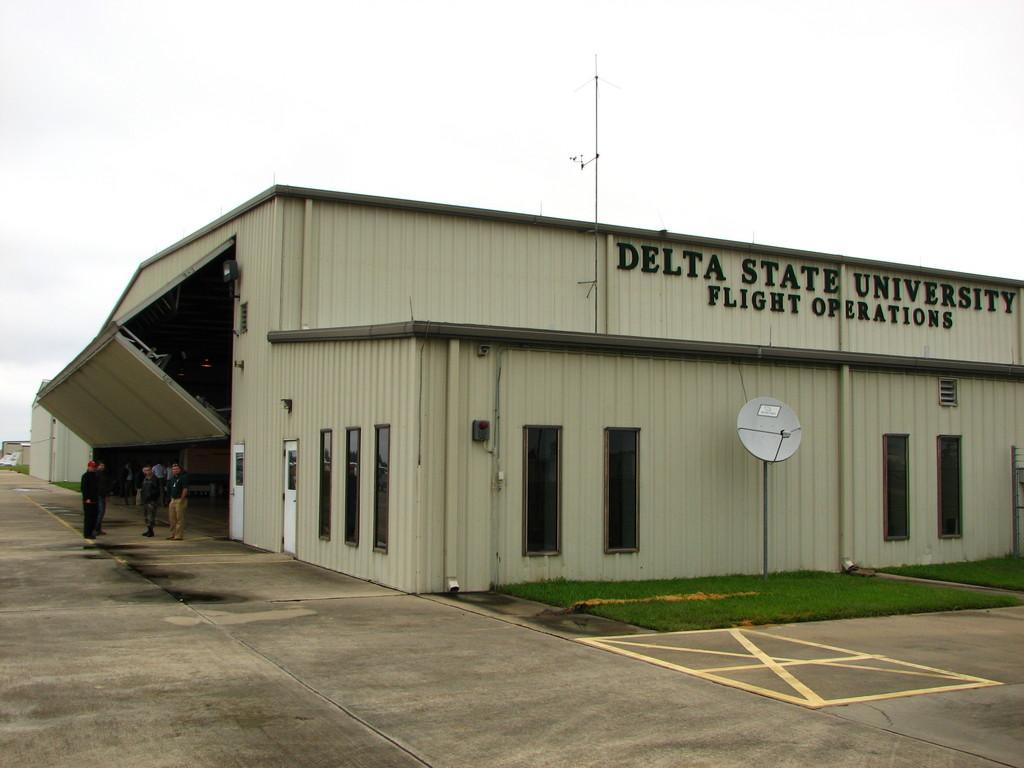Can you describe this image briefly? In the picture we can see a house, shed with a glass windows and a door and name on it Delta state university flight operations, and near to it, we can see a dish with a pole on the grass surface on the path and near the shed we can see some persons standing and in the background we can see a sky. 